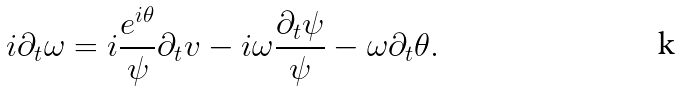<formula> <loc_0><loc_0><loc_500><loc_500>i \partial _ { t } \omega = i \frac { e ^ { i \theta } } { \psi } \partial _ { t } v - i \omega \frac { \partial _ { t } \psi } { \psi } - \omega \partial _ { t } \theta .</formula> 